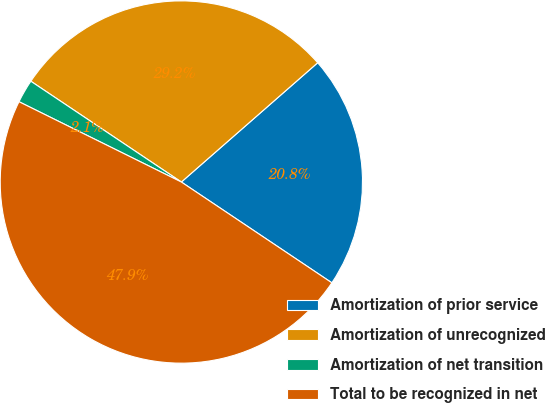<chart> <loc_0><loc_0><loc_500><loc_500><pie_chart><fcel>Amortization of prior service<fcel>Amortization of unrecognized<fcel>Amortization of net transition<fcel>Total to be recognized in net<nl><fcel>20.83%<fcel>29.17%<fcel>2.08%<fcel>47.92%<nl></chart> 